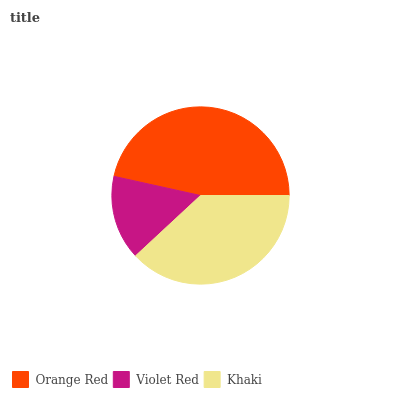Is Violet Red the minimum?
Answer yes or no. Yes. Is Orange Red the maximum?
Answer yes or no. Yes. Is Khaki the minimum?
Answer yes or no. No. Is Khaki the maximum?
Answer yes or no. No. Is Khaki greater than Violet Red?
Answer yes or no. Yes. Is Violet Red less than Khaki?
Answer yes or no. Yes. Is Violet Red greater than Khaki?
Answer yes or no. No. Is Khaki less than Violet Red?
Answer yes or no. No. Is Khaki the high median?
Answer yes or no. Yes. Is Khaki the low median?
Answer yes or no. Yes. Is Orange Red the high median?
Answer yes or no. No. Is Violet Red the low median?
Answer yes or no. No. 